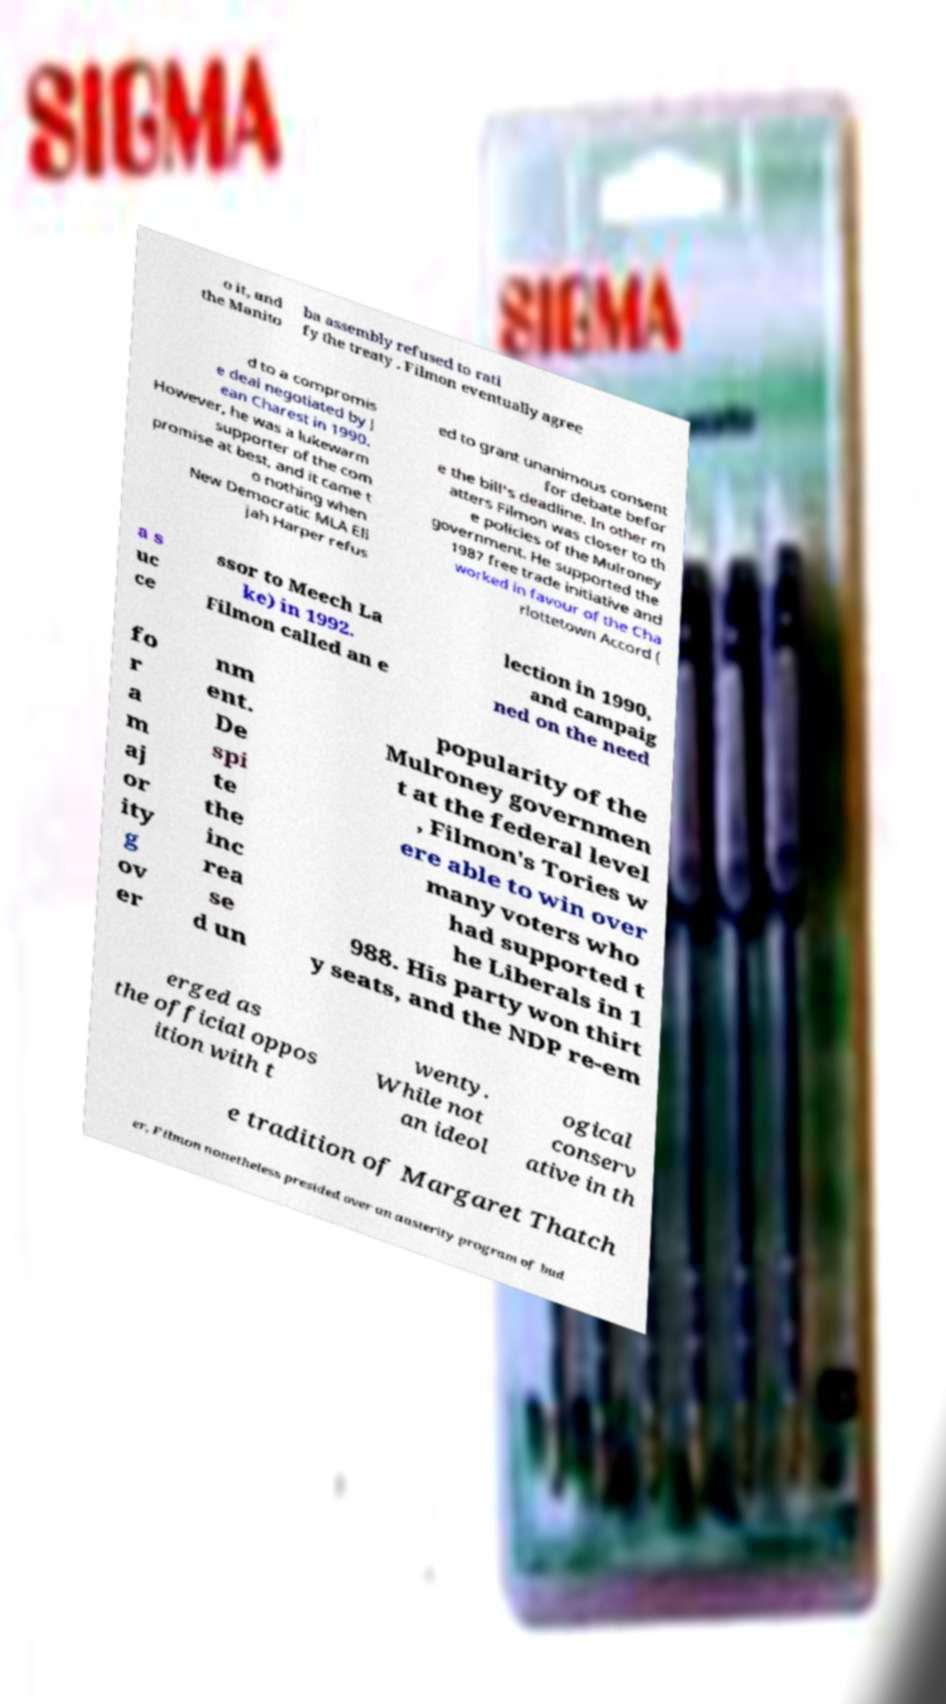There's text embedded in this image that I need extracted. Can you transcribe it verbatim? o it, and the Manito ba assembly refused to rati fy the treaty . Filmon eventually agree d to a compromis e deal negotiated by J ean Charest in 1990. However, he was a lukewarm supporter of the com promise at best, and it came t o nothing when New Democratic MLA Eli jah Harper refus ed to grant unanimous consent for debate befor e the bill's deadline. In other m atters Filmon was closer to th e policies of the Mulroney government. He supported the 1987 free trade initiative and worked in favour of the Cha rlottetown Accord ( a s uc ce ssor to Meech La ke) in 1992. Filmon called an e lection in 1990, and campaig ned on the need fo r a m aj or ity g ov er nm ent. De spi te the inc rea se d un popularity of the Mulroney governmen t at the federal level , Filmon's Tories w ere able to win over many voters who had supported t he Liberals in 1 988. His party won thirt y seats, and the NDP re-em erged as the official oppos ition with t wenty. While not an ideol ogical conserv ative in th e tradition of Margaret Thatch er, Filmon nonetheless presided over an austerity program of bud 